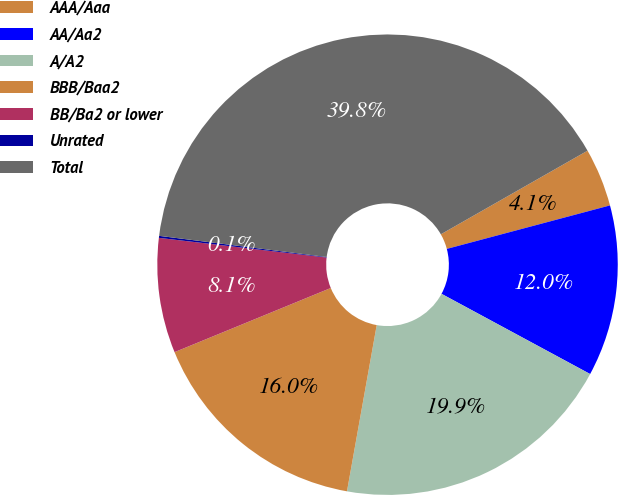Convert chart. <chart><loc_0><loc_0><loc_500><loc_500><pie_chart><fcel>AAA/Aaa<fcel>AA/Aa2<fcel>A/A2<fcel>BBB/Baa2<fcel>BB/Ba2 or lower<fcel>Unrated<fcel>Total<nl><fcel>4.1%<fcel>12.02%<fcel>19.94%<fcel>15.98%<fcel>8.06%<fcel>0.14%<fcel>39.75%<nl></chart> 